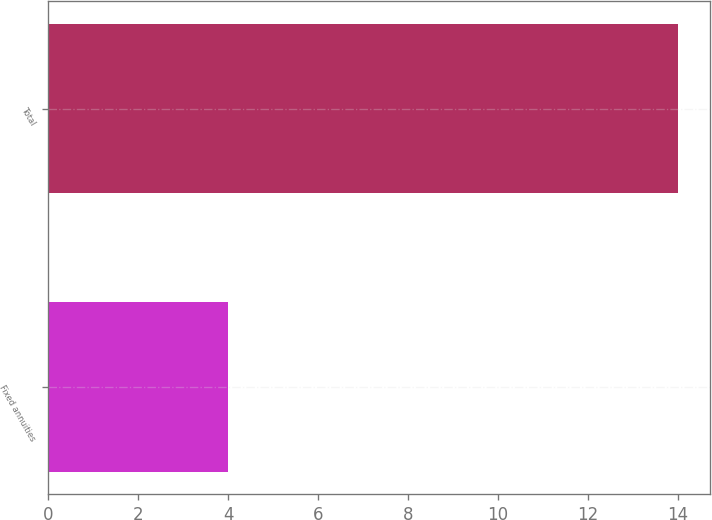Convert chart to OTSL. <chart><loc_0><loc_0><loc_500><loc_500><bar_chart><fcel>Fixed annuities<fcel>Total<nl><fcel>4<fcel>14<nl></chart> 